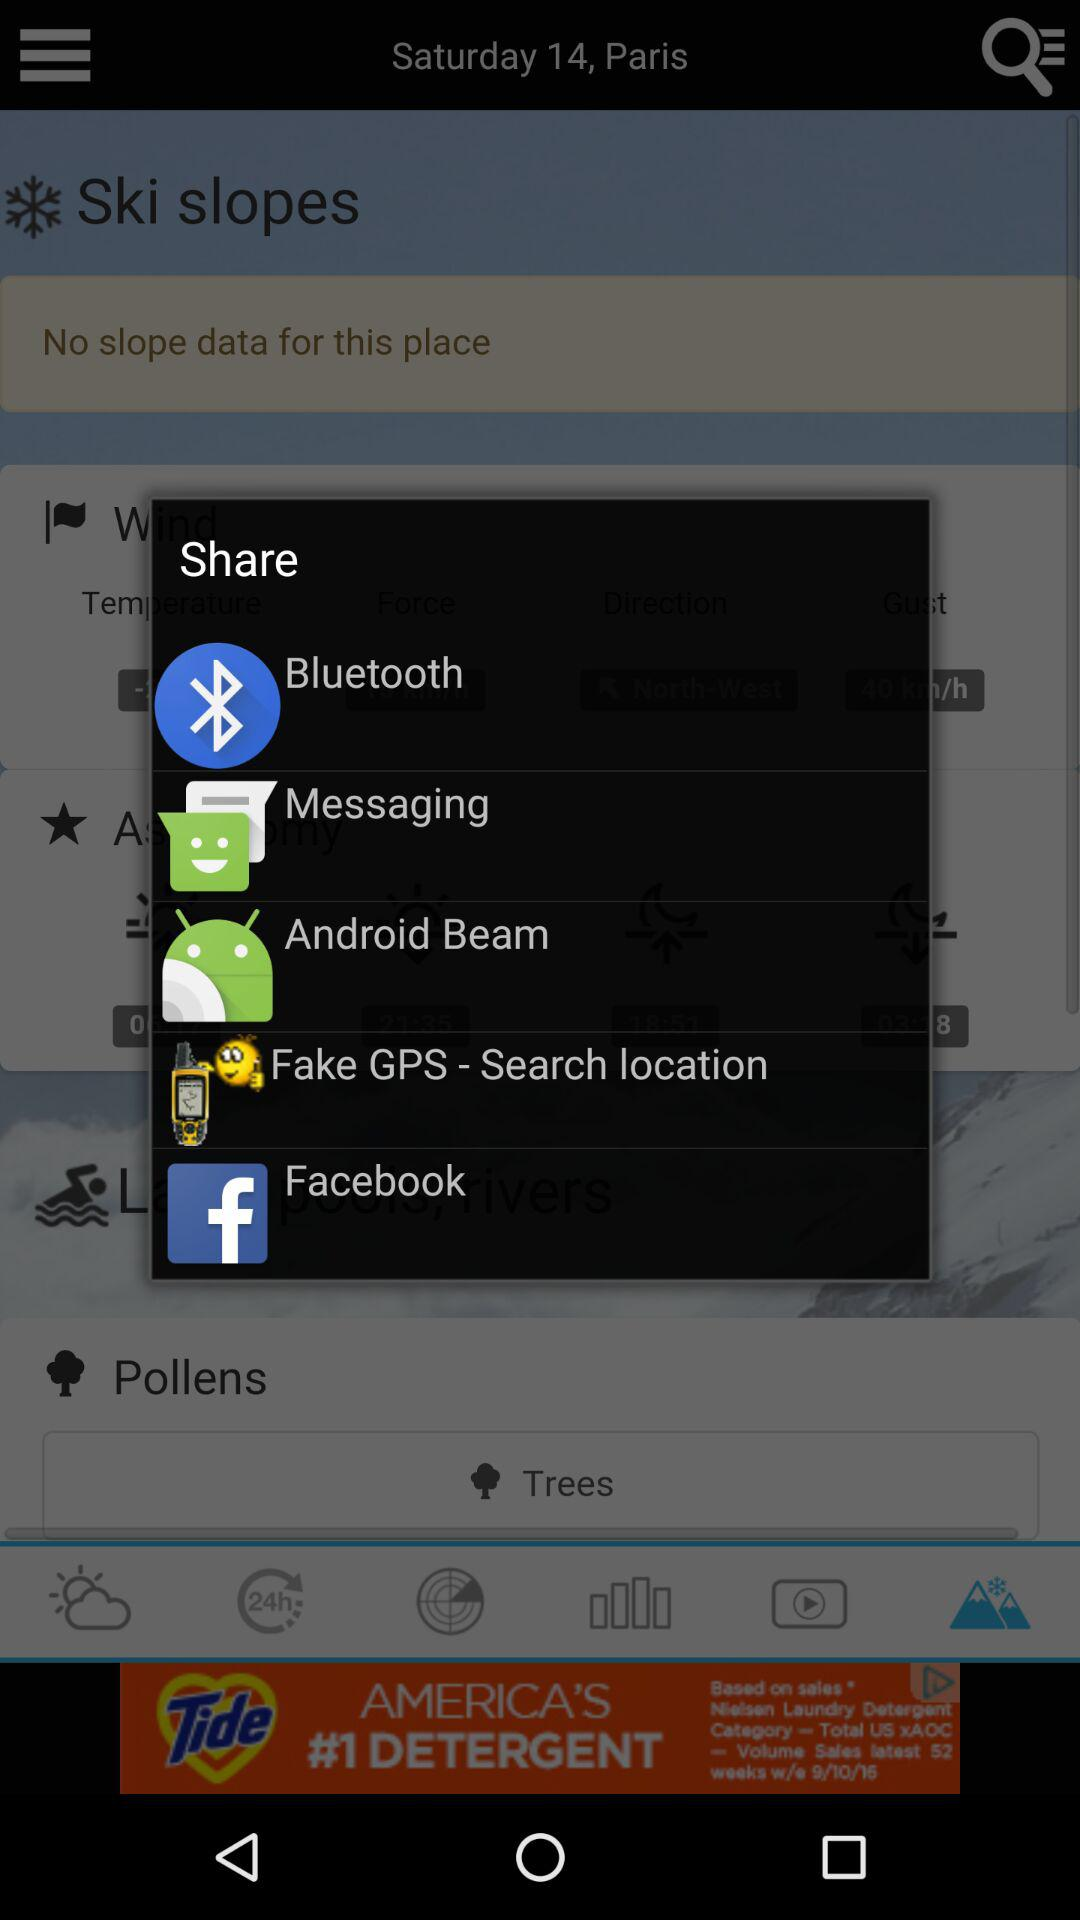What applications can we choose to share? We can share with "Bluetooth", "Messaging", "Android Beam", "Fake GPS - Search location" and "Facebook". 